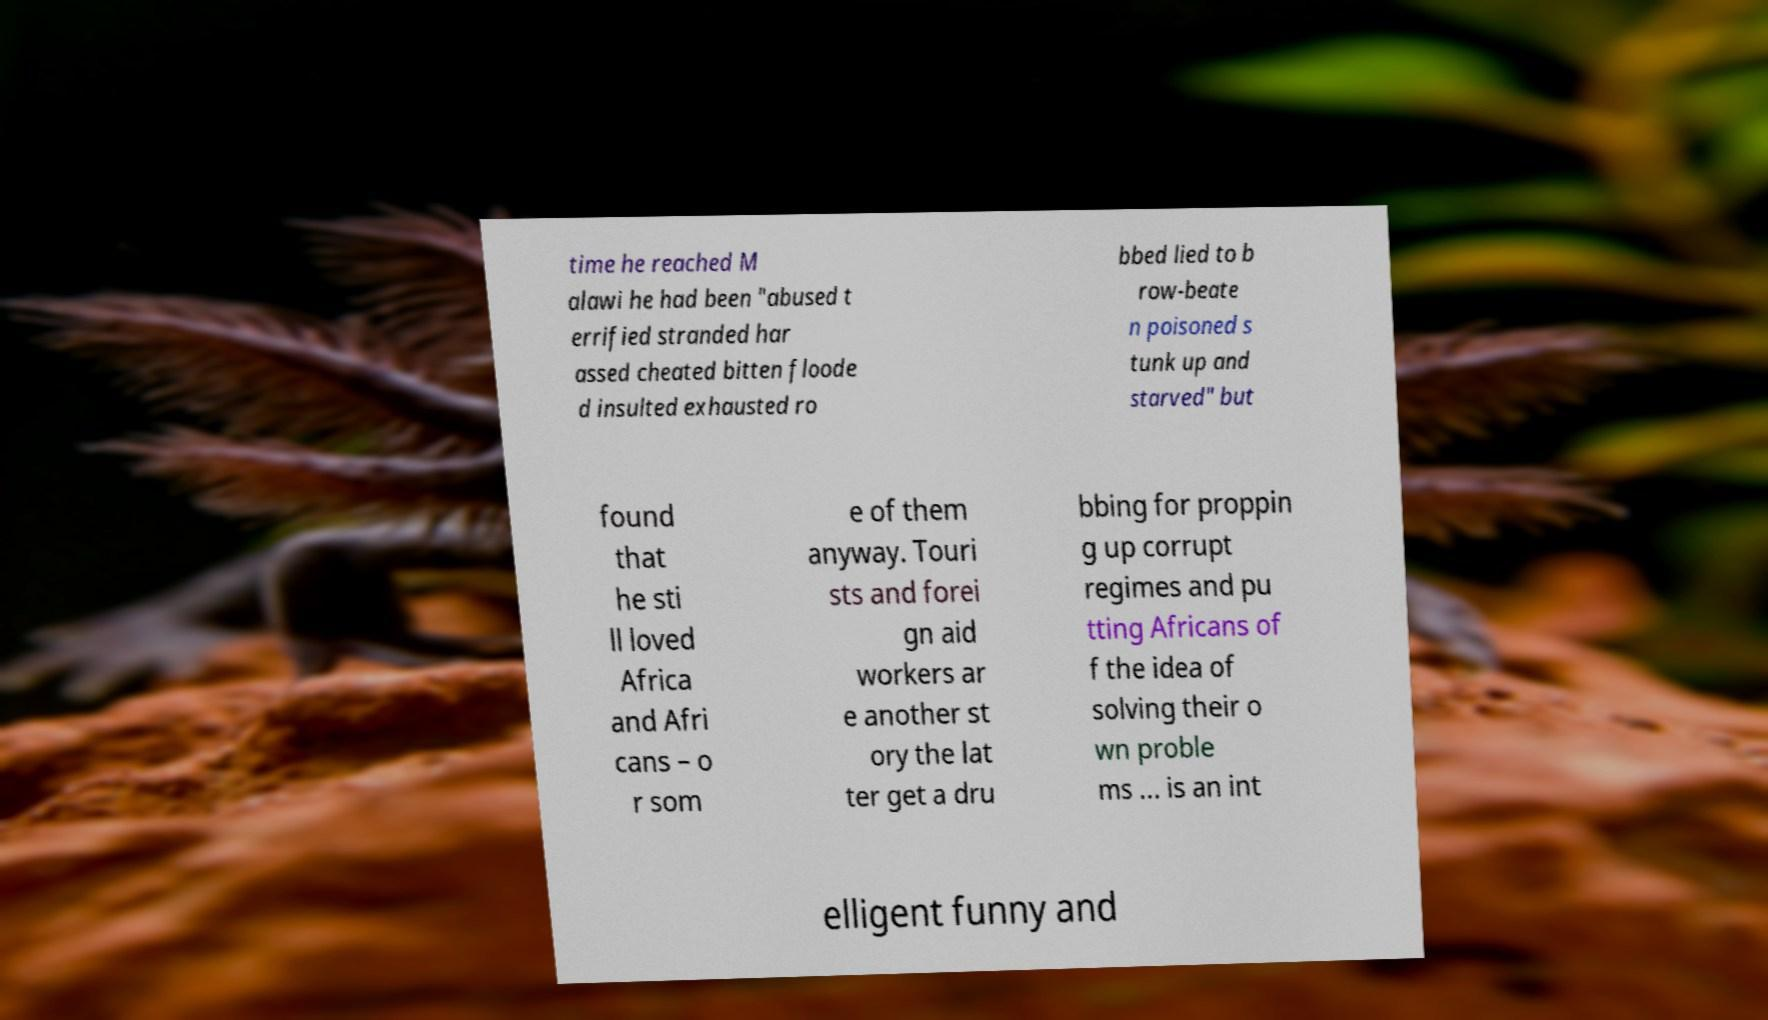Could you extract and type out the text from this image? time he reached M alawi he had been "abused t errified stranded har assed cheated bitten floode d insulted exhausted ro bbed lied to b row-beate n poisoned s tunk up and starved" but found that he sti ll loved Africa and Afri cans – o r som e of them anyway. Touri sts and forei gn aid workers ar e another st ory the lat ter get a dru bbing for proppin g up corrupt regimes and pu tting Africans of f the idea of solving their o wn proble ms ... is an int elligent funny and 